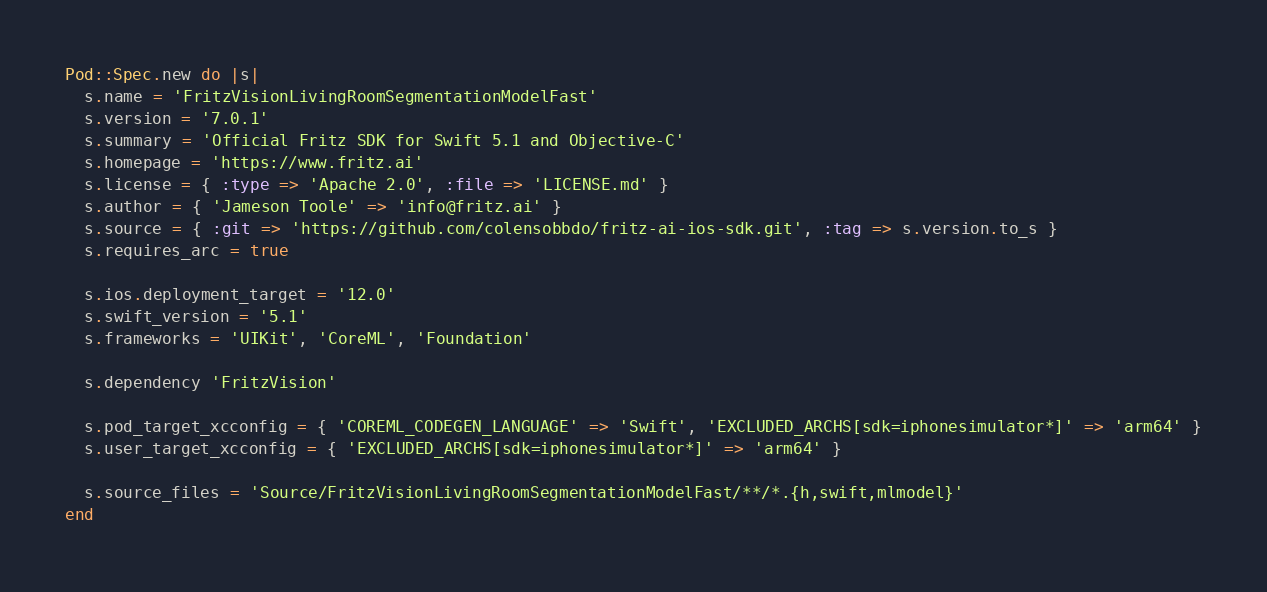<code> <loc_0><loc_0><loc_500><loc_500><_Ruby_>Pod::Spec.new do |s|
  s.name = 'FritzVisionLivingRoomSegmentationModelFast'
  s.version = '7.0.1'
  s.summary = 'Official Fritz SDK for Swift 5.1 and Objective-C'
  s.homepage = 'https://www.fritz.ai'
  s.license = { :type => 'Apache 2.0', :file => 'LICENSE.md' }
  s.author = { 'Jameson Toole' => 'info@fritz.ai' }
  s.source = { :git => 'https://github.com/colensobbdo/fritz-ai-ios-sdk.git', :tag => s.version.to_s }
  s.requires_arc = true

  s.ios.deployment_target = '12.0'
  s.swift_version = '5.1'
  s.frameworks = 'UIKit', 'CoreML', 'Foundation'

  s.dependency 'FritzVision'

  s.pod_target_xcconfig = { 'COREML_CODEGEN_LANGUAGE' => 'Swift', 'EXCLUDED_ARCHS[sdk=iphonesimulator*]' => 'arm64' }
  s.user_target_xcconfig = { 'EXCLUDED_ARCHS[sdk=iphonesimulator*]' => 'arm64' }

  s.source_files = 'Source/FritzVisionLivingRoomSegmentationModelFast/**/*.{h,swift,mlmodel}'
end
</code> 